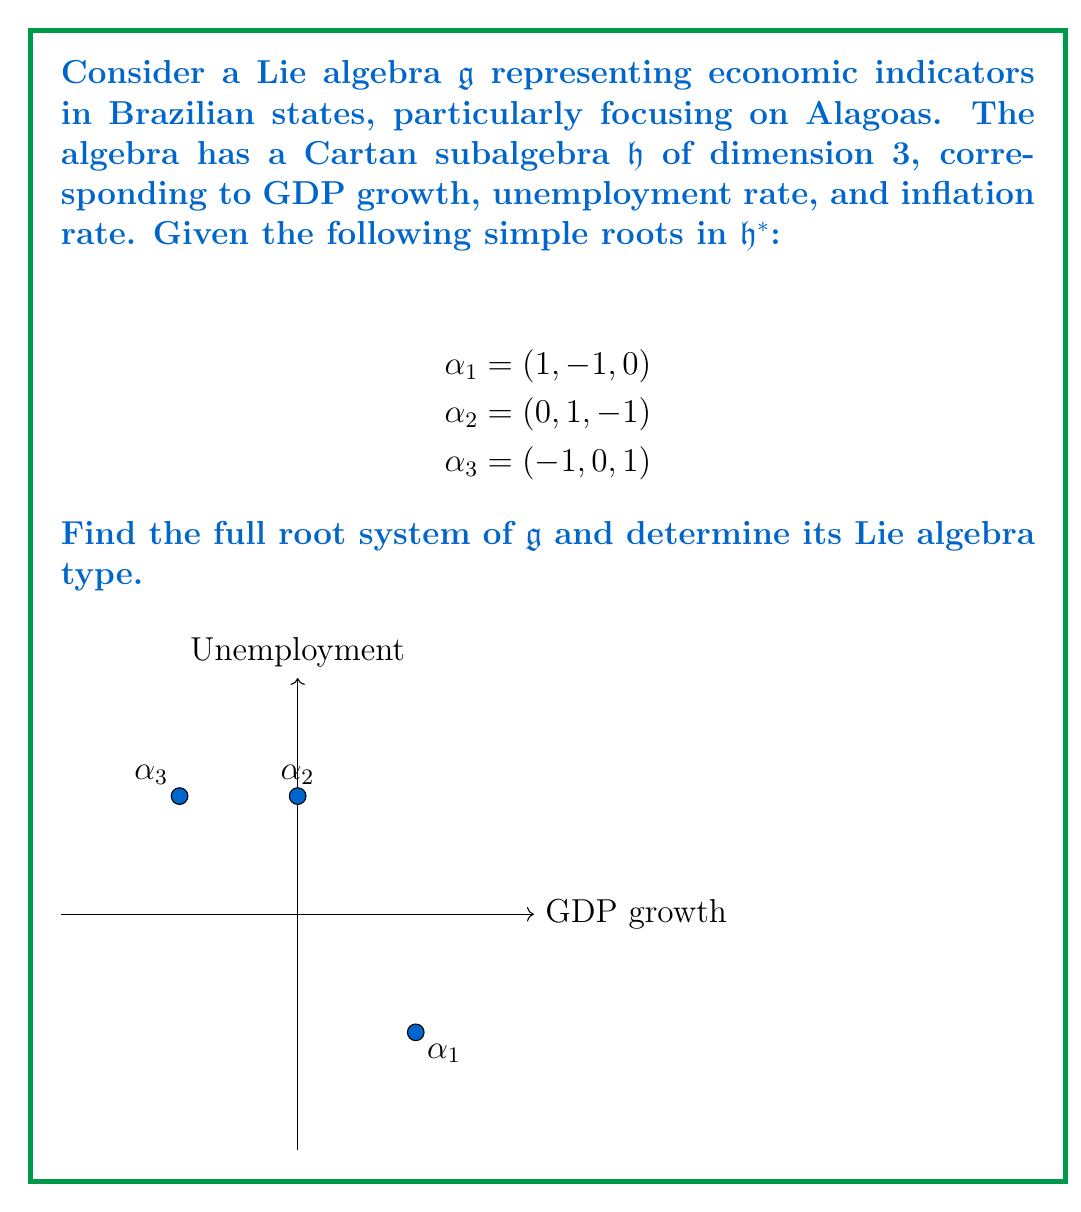What is the answer to this math problem? To find the full root system and determine the Lie algebra type, we'll follow these steps:

1) First, we need to find all positive roots. We start with the simple roots and add them to find new roots until no new roots are generated.

   $\alpha_1 = (1, -1, 0)$
   $\alpha_2 = (0, 1, -1)$
   $\alpha_3 = (-1, 0, 1)$

   $\alpha_1 + \alpha_2 = (1, 0, -1)$
   $\alpha_2 + \alpha_3 = (-1, 1, 0)$
   $\alpha_1 + \alpha_2 + \alpha_3 = (0, 0, 0)$ (this is not a root)

2) The negative of each root is also a root. So the full root system is:

   $\pm(1, -1, 0)$, $\pm(0, 1, -1)$, $\pm(-1, 0, 1)$, $\pm(1, 0, -1)$, $\pm(-1, 1, 0)$

3) To determine the Lie algebra type, we need to count the number of positive roots and the rank of the algebra.

   Number of positive roots = 5
   Rank (dimension of Cartan subalgebra) = 3

4) Looking at the classification of simple Lie algebras, we find that $A_3$ (or $\mathfrak{sl}(4)$) has rank 3 and 6 positive roots. Our algebra has rank 3 but only 5 positive roots.

5) The only simple Lie algebra of rank 3 with 5 positive roots is $C_3$ (or $\mathfrak{sp}(6)$).

Therefore, the Lie algebra $\mathfrak{g}$ representing these economic indicators is of type $C_3$.
Answer: Root system: $\pm(1, -1, 0)$, $\pm(0, 1, -1)$, $\pm(-1, 0, 1)$, $\pm(1, 0, -1)$, $\pm(-1, 1, 0)$; Type: $C_3$ 